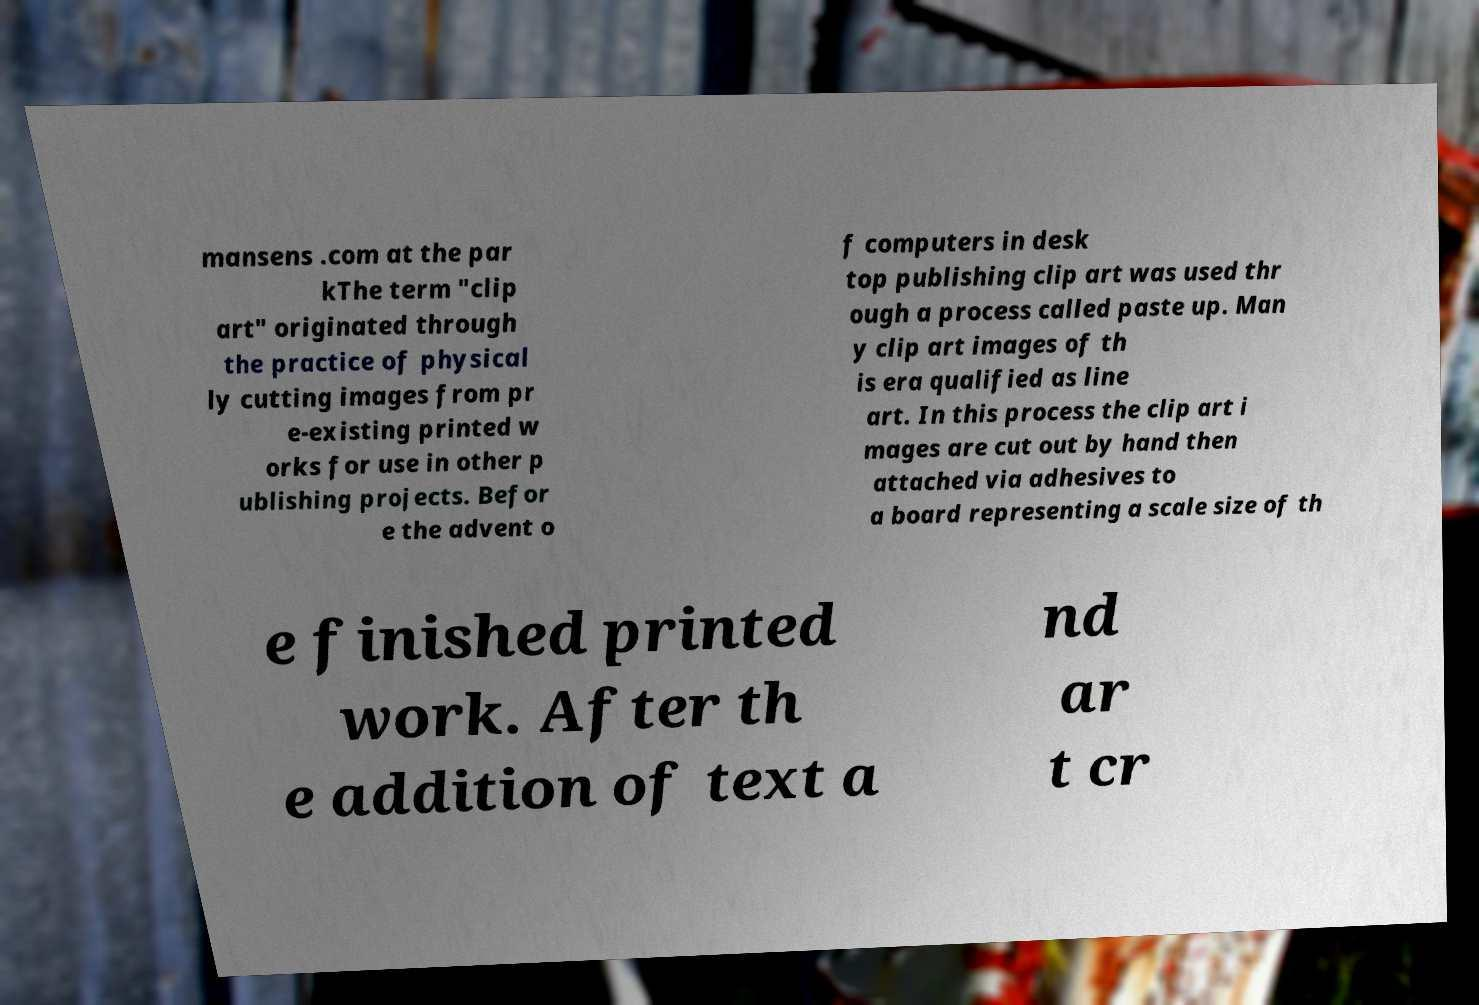Could you assist in decoding the text presented in this image and type it out clearly? mansens .com at the par kThe term "clip art" originated through the practice of physical ly cutting images from pr e-existing printed w orks for use in other p ublishing projects. Befor e the advent o f computers in desk top publishing clip art was used thr ough a process called paste up. Man y clip art images of th is era qualified as line art. In this process the clip art i mages are cut out by hand then attached via adhesives to a board representing a scale size of th e finished printed work. After th e addition of text a nd ar t cr 